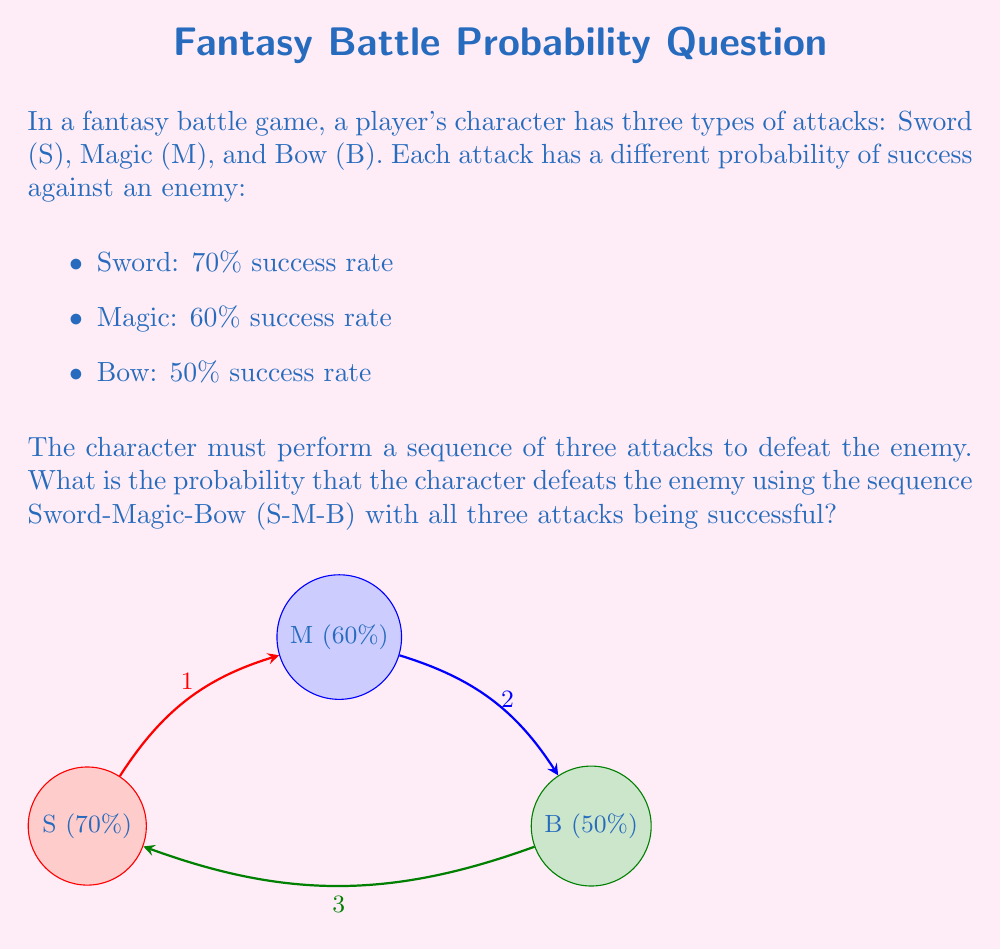Can you answer this question? To solve this problem, we need to understand the concept of independent events and how to calculate their combined probability. In this case, each attack is an independent event, and we want all three to be successful.

Step 1: Identify the probabilities for each attack in the sequence.
- Sword (S): $P(S) = 0.70$
- Magic (M): $P(M) = 0.60$
- Bow (B): $P(B) = 0.50$

Step 2: Calculate the probability of all three attacks being successful.
Since these are independent events, we multiply their individual probabilities:

$$P(\text{S and M and B}) = P(S) \times P(M) \times P(B)$$

Step 3: Substitute the values and calculate.
$$P(\text{S and M and B}) = 0.70 \times 0.60 \times 0.50$$

Step 4: Perform the multiplication.
$$P(\text{S and M and B}) = 0.21$$

Therefore, the probability of the character defeating the enemy using the S-M-B sequence with all three attacks being successful is 0.21 or 21%.
Answer: $0.21$ or $21\%$ 